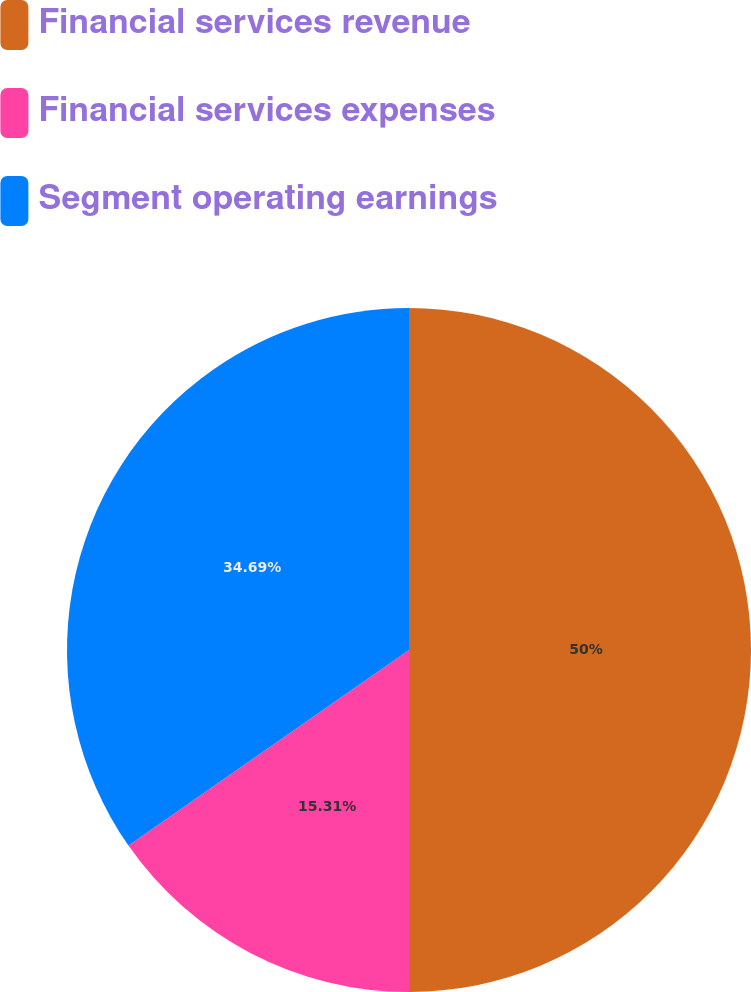Convert chart. <chart><loc_0><loc_0><loc_500><loc_500><pie_chart><fcel>Financial services revenue<fcel>Financial services expenses<fcel>Segment operating earnings<nl><fcel>50.0%<fcel>15.31%<fcel>34.69%<nl></chart> 